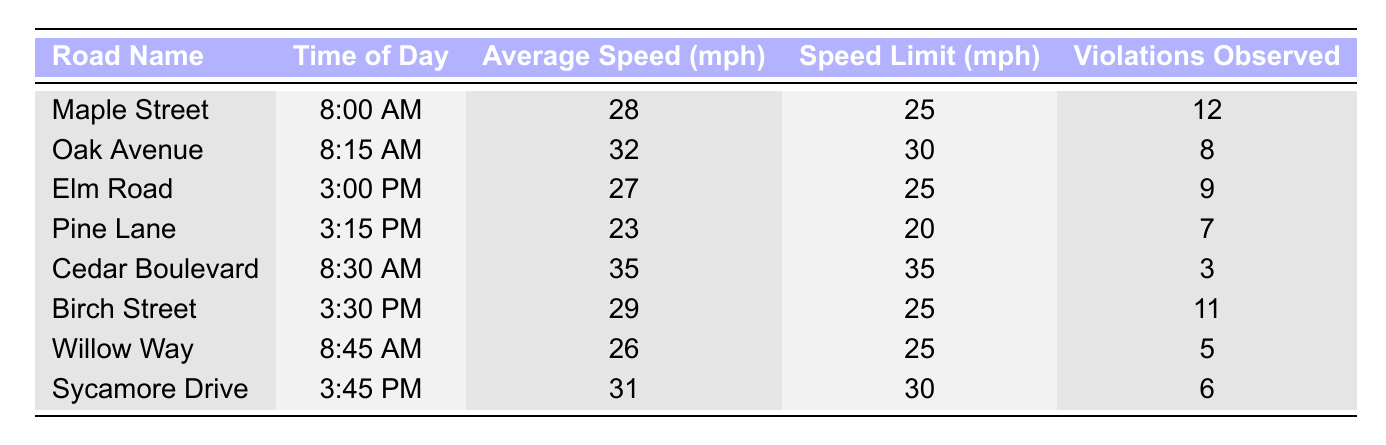What was the average speed on Maple Street at 8:00 AM? The table indicates that the average speed on Maple Street at 8:00 AM is 28 mph.
Answer: 28 mph How many violations were observed on Oak Avenue at 8:15 AM? According to the table, 8 violations were observed on Oak Avenue at 8:15 AM.
Answer: 8 Is the average speed on Pine Lane at 3:15 PM over the speed limit? The average speed on Pine Lane is 23 mph and the speed limit is 20 mph, so the average speed exceeds the speed limit.
Answer: Yes What is the total number of violations observed during the morning times? To find the total number of violations in the morning (8:00 AM, 8:15 AM, and 8:30 AM), add 12 (Maple Street) + 8 (Oak Avenue) + 3 (Cedar Boulevard) = 23.
Answer: 23 Which road had the highest average speed, and what was that speed? Cedar Boulevard had the highest average speed of 35 mph, measured at 8:30 AM.
Answer: Cedar Boulevard, 35 mph During which time of day was the lowest average speed recorded, and what was that speed? The lowest average speed was recorded on Pine Lane at 3:15 PM, which was 23 mph.
Answer: 3:15 PM, 23 mph How many roads had an average speed exceeding their speed limit during the afternoon? Analyzing the afternoon data, Elm Road (average speed 27 mph, limit 25 mph) and Birch Street (29 mph, limit 25 mph) exceeded the speed limit, making it 2 roads.
Answer: 2 What is the average number of violations observed across all roads? To find the average number of violations, sum them: 12 + 8 + 9 + 7 + 3 + 11 + 5 + 6 = 61, then divide by 8 (the number of entries), which is 61/8 = 7.625.
Answer: 7.625 